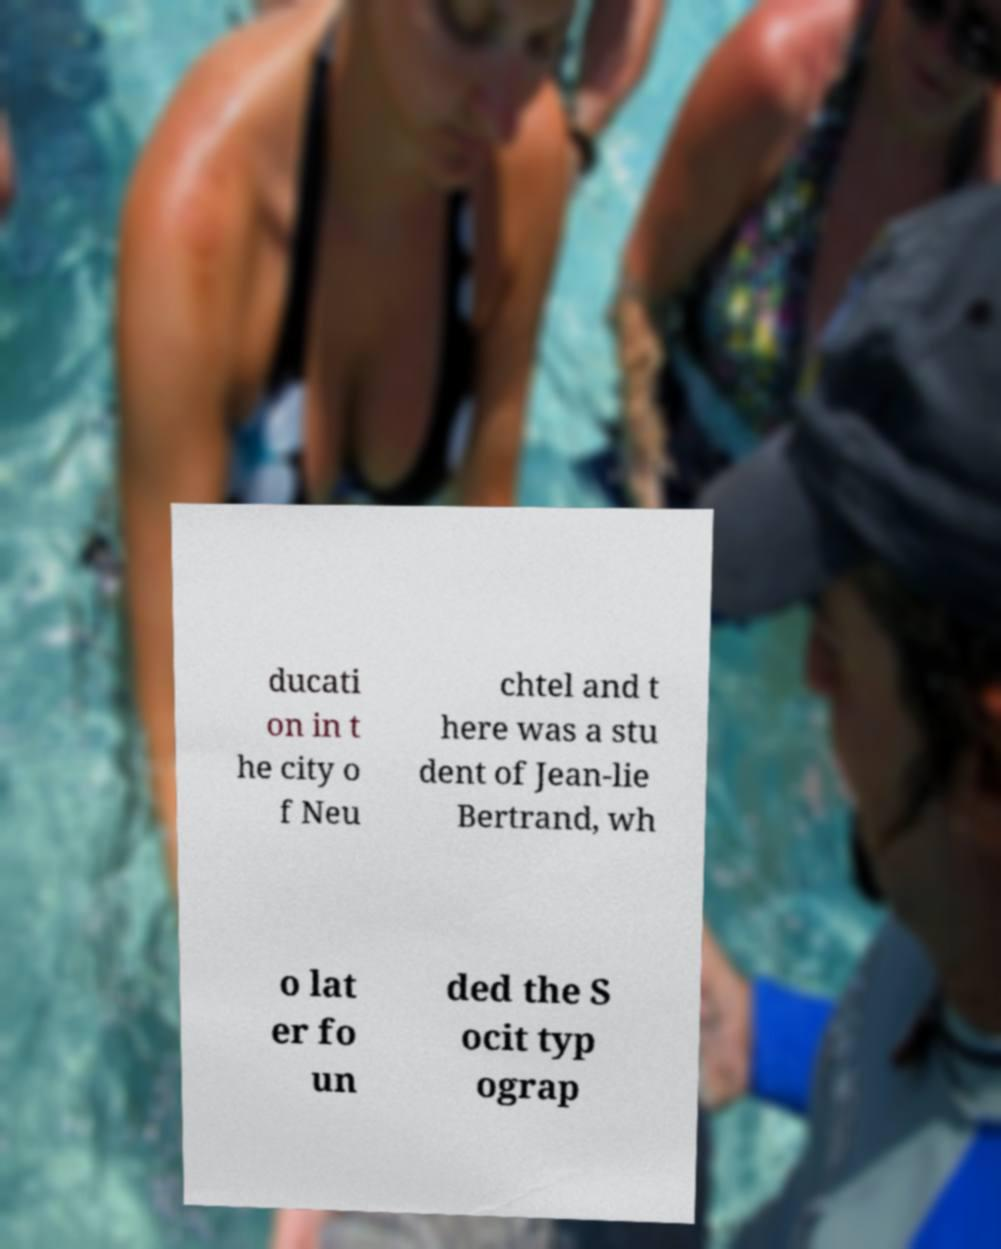Please read and relay the text visible in this image. What does it say? ducati on in t he city o f Neu chtel and t here was a stu dent of Jean-lie Bertrand, wh o lat er fo un ded the S ocit typ ograp 